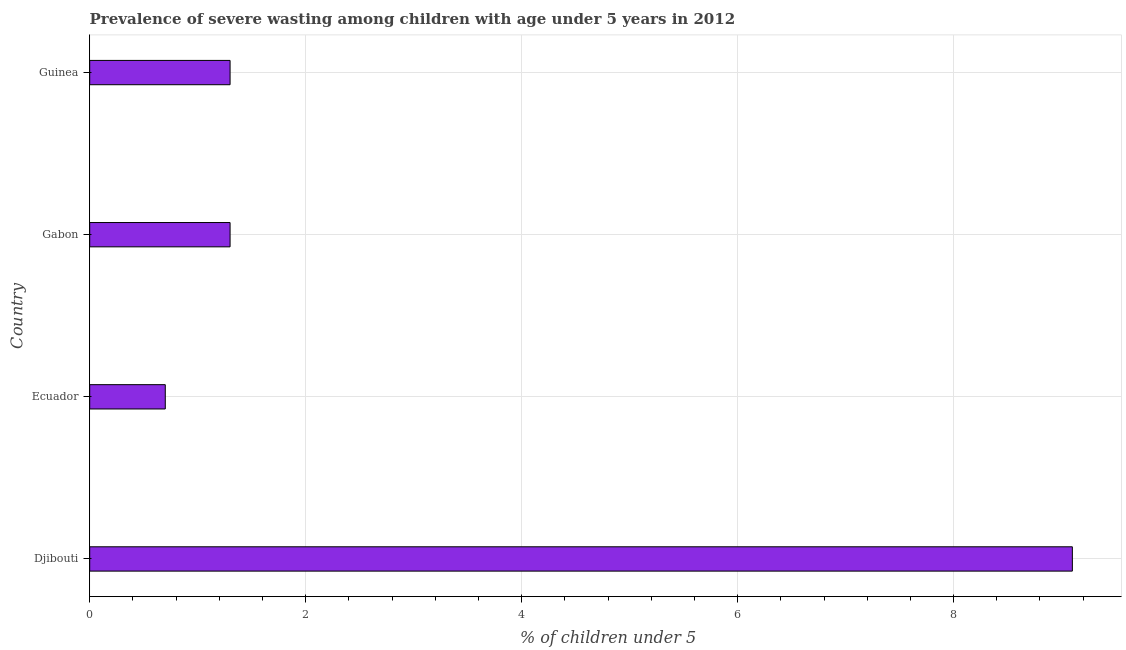Does the graph contain any zero values?
Provide a short and direct response. No. What is the title of the graph?
Offer a very short reply. Prevalence of severe wasting among children with age under 5 years in 2012. What is the label or title of the X-axis?
Provide a succinct answer.  % of children under 5. What is the prevalence of severe wasting in Guinea?
Give a very brief answer. 1.3. Across all countries, what is the maximum prevalence of severe wasting?
Your answer should be compact. 9.1. Across all countries, what is the minimum prevalence of severe wasting?
Ensure brevity in your answer.  0.7. In which country was the prevalence of severe wasting maximum?
Your answer should be compact. Djibouti. In which country was the prevalence of severe wasting minimum?
Your response must be concise. Ecuador. What is the sum of the prevalence of severe wasting?
Offer a terse response. 12.4. What is the difference between the prevalence of severe wasting in Gabon and Guinea?
Your answer should be very brief. 0. What is the average prevalence of severe wasting per country?
Keep it short and to the point. 3.1. What is the median prevalence of severe wasting?
Make the answer very short. 1.3. In how many countries, is the prevalence of severe wasting greater than 8.4 %?
Your response must be concise. 1. What is the ratio of the prevalence of severe wasting in Djibouti to that in Guinea?
Your response must be concise. 7. Is the prevalence of severe wasting in Gabon less than that in Guinea?
Ensure brevity in your answer.  No. Is the difference between the prevalence of severe wasting in Djibouti and Gabon greater than the difference between any two countries?
Your answer should be compact. No. What is the difference between the highest and the second highest prevalence of severe wasting?
Offer a terse response. 7.8. Is the sum of the prevalence of severe wasting in Djibouti and Guinea greater than the maximum prevalence of severe wasting across all countries?
Keep it short and to the point. Yes. Are all the bars in the graph horizontal?
Provide a short and direct response. Yes. What is the difference between two consecutive major ticks on the X-axis?
Provide a short and direct response. 2. What is the  % of children under 5 of Djibouti?
Make the answer very short. 9.1. What is the  % of children under 5 in Ecuador?
Keep it short and to the point. 0.7. What is the  % of children under 5 in Gabon?
Give a very brief answer. 1.3. What is the  % of children under 5 of Guinea?
Your answer should be very brief. 1.3. What is the difference between the  % of children under 5 in Djibouti and Guinea?
Give a very brief answer. 7.8. What is the difference between the  % of children under 5 in Ecuador and Gabon?
Your response must be concise. -0.6. What is the difference between the  % of children under 5 in Ecuador and Guinea?
Offer a terse response. -0.6. What is the ratio of the  % of children under 5 in Djibouti to that in Gabon?
Offer a terse response. 7. What is the ratio of the  % of children under 5 in Ecuador to that in Gabon?
Offer a very short reply. 0.54. What is the ratio of the  % of children under 5 in Ecuador to that in Guinea?
Your response must be concise. 0.54. 